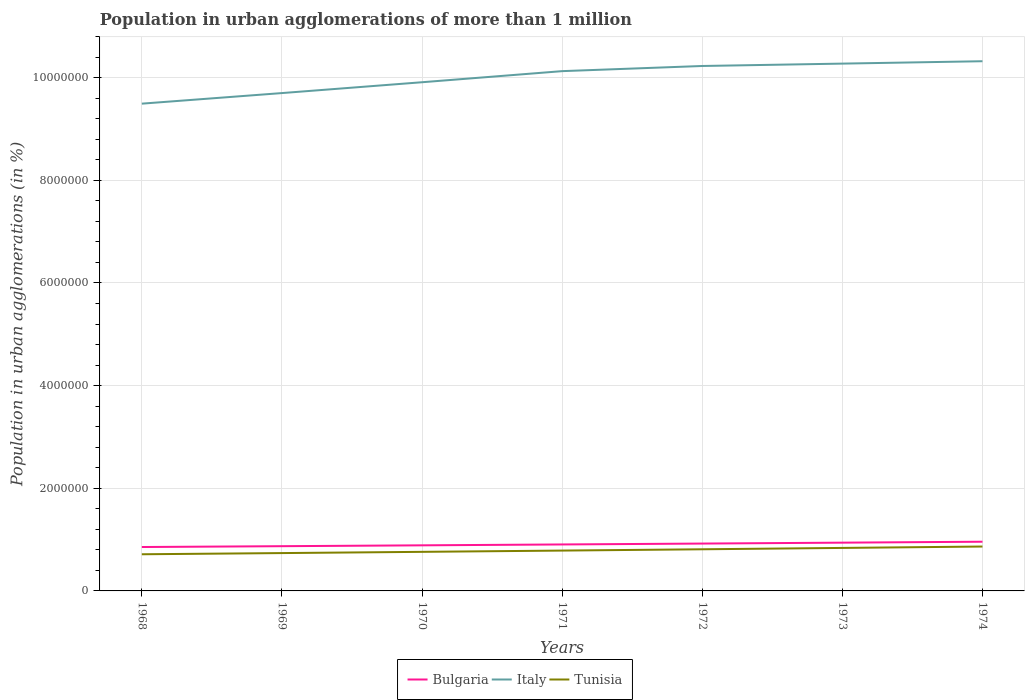Does the line corresponding to Bulgaria intersect with the line corresponding to Tunisia?
Ensure brevity in your answer.  No. Across all years, what is the maximum population in urban agglomerations in Bulgaria?
Make the answer very short. 8.55e+05. In which year was the population in urban agglomerations in Tunisia maximum?
Make the answer very short. 1968. What is the total population in urban agglomerations in Italy in the graph?
Ensure brevity in your answer.  -5.28e+05. What is the difference between the highest and the second highest population in urban agglomerations in Italy?
Your answer should be compact. 8.27e+05. Is the population in urban agglomerations in Tunisia strictly greater than the population in urban agglomerations in Bulgaria over the years?
Your answer should be compact. Yes. How many lines are there?
Give a very brief answer. 3. Are the values on the major ticks of Y-axis written in scientific E-notation?
Give a very brief answer. No. Does the graph contain grids?
Give a very brief answer. Yes. How many legend labels are there?
Give a very brief answer. 3. How are the legend labels stacked?
Make the answer very short. Horizontal. What is the title of the graph?
Offer a terse response. Population in urban agglomerations of more than 1 million. Does "Macedonia" appear as one of the legend labels in the graph?
Provide a short and direct response. No. What is the label or title of the X-axis?
Keep it short and to the point. Years. What is the label or title of the Y-axis?
Your answer should be very brief. Population in urban agglomerations (in %). What is the Population in urban agglomerations (in %) of Bulgaria in 1968?
Offer a very short reply. 8.55e+05. What is the Population in urban agglomerations (in %) of Italy in 1968?
Ensure brevity in your answer.  9.49e+06. What is the Population in urban agglomerations (in %) of Tunisia in 1968?
Offer a very short reply. 7.14e+05. What is the Population in urban agglomerations (in %) of Bulgaria in 1969?
Provide a succinct answer. 8.72e+05. What is the Population in urban agglomerations (in %) of Italy in 1969?
Your answer should be very brief. 9.70e+06. What is the Population in urban agglomerations (in %) of Tunisia in 1969?
Make the answer very short. 7.37e+05. What is the Population in urban agglomerations (in %) in Bulgaria in 1970?
Offer a very short reply. 8.88e+05. What is the Population in urban agglomerations (in %) of Italy in 1970?
Keep it short and to the point. 9.91e+06. What is the Population in urban agglomerations (in %) in Tunisia in 1970?
Ensure brevity in your answer.  7.61e+05. What is the Population in urban agglomerations (in %) of Bulgaria in 1971?
Offer a terse response. 9.05e+05. What is the Population in urban agglomerations (in %) in Italy in 1971?
Give a very brief answer. 1.01e+07. What is the Population in urban agglomerations (in %) in Tunisia in 1971?
Your response must be concise. 7.86e+05. What is the Population in urban agglomerations (in %) of Bulgaria in 1972?
Keep it short and to the point. 9.23e+05. What is the Population in urban agglomerations (in %) in Italy in 1972?
Ensure brevity in your answer.  1.02e+07. What is the Population in urban agglomerations (in %) in Tunisia in 1972?
Give a very brief answer. 8.11e+05. What is the Population in urban agglomerations (in %) in Bulgaria in 1973?
Provide a short and direct response. 9.41e+05. What is the Population in urban agglomerations (in %) of Italy in 1973?
Provide a short and direct response. 1.03e+07. What is the Population in urban agglomerations (in %) in Tunisia in 1973?
Your response must be concise. 8.38e+05. What is the Population in urban agglomerations (in %) in Bulgaria in 1974?
Your response must be concise. 9.59e+05. What is the Population in urban agglomerations (in %) of Italy in 1974?
Make the answer very short. 1.03e+07. What is the Population in urban agglomerations (in %) of Tunisia in 1974?
Offer a terse response. 8.65e+05. Across all years, what is the maximum Population in urban agglomerations (in %) of Bulgaria?
Keep it short and to the point. 9.59e+05. Across all years, what is the maximum Population in urban agglomerations (in %) in Italy?
Provide a short and direct response. 1.03e+07. Across all years, what is the maximum Population in urban agglomerations (in %) in Tunisia?
Ensure brevity in your answer.  8.65e+05. Across all years, what is the minimum Population in urban agglomerations (in %) in Bulgaria?
Ensure brevity in your answer.  8.55e+05. Across all years, what is the minimum Population in urban agglomerations (in %) of Italy?
Your answer should be compact. 9.49e+06. Across all years, what is the minimum Population in urban agglomerations (in %) in Tunisia?
Offer a very short reply. 7.14e+05. What is the total Population in urban agglomerations (in %) of Bulgaria in the graph?
Your response must be concise. 6.34e+06. What is the total Population in urban agglomerations (in %) in Italy in the graph?
Ensure brevity in your answer.  7.01e+07. What is the total Population in urban agglomerations (in %) of Tunisia in the graph?
Provide a short and direct response. 5.51e+06. What is the difference between the Population in urban agglomerations (in %) of Bulgaria in 1968 and that in 1969?
Your response must be concise. -1.64e+04. What is the difference between the Population in urban agglomerations (in %) of Italy in 1968 and that in 1969?
Your answer should be compact. -2.06e+05. What is the difference between the Population in urban agglomerations (in %) in Tunisia in 1968 and that in 1969?
Your answer should be very brief. -2.31e+04. What is the difference between the Population in urban agglomerations (in %) of Bulgaria in 1968 and that in 1970?
Provide a short and direct response. -3.31e+04. What is the difference between the Population in urban agglomerations (in %) of Italy in 1968 and that in 1970?
Provide a short and direct response. -4.17e+05. What is the difference between the Population in urban agglomerations (in %) in Tunisia in 1968 and that in 1970?
Your response must be concise. -4.70e+04. What is the difference between the Population in urban agglomerations (in %) in Bulgaria in 1968 and that in 1971?
Make the answer very short. -5.02e+04. What is the difference between the Population in urban agglomerations (in %) in Italy in 1968 and that in 1971?
Offer a terse response. -6.33e+05. What is the difference between the Population in urban agglomerations (in %) of Tunisia in 1968 and that in 1971?
Give a very brief answer. -7.17e+04. What is the difference between the Population in urban agglomerations (in %) in Bulgaria in 1968 and that in 1972?
Make the answer very short. -6.76e+04. What is the difference between the Population in urban agglomerations (in %) in Italy in 1968 and that in 1972?
Your answer should be compact. -7.34e+05. What is the difference between the Population in urban agglomerations (in %) of Tunisia in 1968 and that in 1972?
Give a very brief answer. -9.72e+04. What is the difference between the Population in urban agglomerations (in %) in Bulgaria in 1968 and that in 1973?
Make the answer very short. -8.52e+04. What is the difference between the Population in urban agglomerations (in %) in Italy in 1968 and that in 1973?
Ensure brevity in your answer.  -7.80e+05. What is the difference between the Population in urban agglomerations (in %) of Tunisia in 1968 and that in 1973?
Your answer should be compact. -1.23e+05. What is the difference between the Population in urban agglomerations (in %) in Bulgaria in 1968 and that in 1974?
Your answer should be very brief. -1.03e+05. What is the difference between the Population in urban agglomerations (in %) of Italy in 1968 and that in 1974?
Offer a very short reply. -8.27e+05. What is the difference between the Population in urban agglomerations (in %) of Tunisia in 1968 and that in 1974?
Provide a short and direct response. -1.51e+05. What is the difference between the Population in urban agglomerations (in %) of Bulgaria in 1969 and that in 1970?
Provide a short and direct response. -1.67e+04. What is the difference between the Population in urban agglomerations (in %) of Italy in 1969 and that in 1970?
Provide a short and direct response. -2.11e+05. What is the difference between the Population in urban agglomerations (in %) in Tunisia in 1969 and that in 1970?
Provide a succinct answer. -2.39e+04. What is the difference between the Population in urban agglomerations (in %) in Bulgaria in 1969 and that in 1971?
Your answer should be compact. -3.38e+04. What is the difference between the Population in urban agglomerations (in %) in Italy in 1969 and that in 1971?
Your answer should be compact. -4.27e+05. What is the difference between the Population in urban agglomerations (in %) of Tunisia in 1969 and that in 1971?
Your response must be concise. -4.86e+04. What is the difference between the Population in urban agglomerations (in %) of Bulgaria in 1969 and that in 1972?
Provide a short and direct response. -5.12e+04. What is the difference between the Population in urban agglomerations (in %) in Italy in 1969 and that in 1972?
Offer a very short reply. -5.28e+05. What is the difference between the Population in urban agglomerations (in %) of Tunisia in 1969 and that in 1972?
Make the answer very short. -7.41e+04. What is the difference between the Population in urban agglomerations (in %) of Bulgaria in 1969 and that in 1973?
Offer a terse response. -6.88e+04. What is the difference between the Population in urban agglomerations (in %) of Italy in 1969 and that in 1973?
Your answer should be very brief. -5.74e+05. What is the difference between the Population in urban agglomerations (in %) of Tunisia in 1969 and that in 1973?
Your answer should be very brief. -1.00e+05. What is the difference between the Population in urban agglomerations (in %) in Bulgaria in 1969 and that in 1974?
Make the answer very short. -8.69e+04. What is the difference between the Population in urban agglomerations (in %) in Italy in 1969 and that in 1974?
Ensure brevity in your answer.  -6.20e+05. What is the difference between the Population in urban agglomerations (in %) in Tunisia in 1969 and that in 1974?
Your response must be concise. -1.27e+05. What is the difference between the Population in urban agglomerations (in %) of Bulgaria in 1970 and that in 1971?
Your answer should be compact. -1.70e+04. What is the difference between the Population in urban agglomerations (in %) in Italy in 1970 and that in 1971?
Offer a terse response. -2.16e+05. What is the difference between the Population in urban agglomerations (in %) of Tunisia in 1970 and that in 1971?
Provide a short and direct response. -2.47e+04. What is the difference between the Population in urban agglomerations (in %) of Bulgaria in 1970 and that in 1972?
Your response must be concise. -3.44e+04. What is the difference between the Population in urban agglomerations (in %) of Italy in 1970 and that in 1972?
Ensure brevity in your answer.  -3.17e+05. What is the difference between the Population in urban agglomerations (in %) of Tunisia in 1970 and that in 1972?
Give a very brief answer. -5.02e+04. What is the difference between the Population in urban agglomerations (in %) in Bulgaria in 1970 and that in 1973?
Make the answer very short. -5.21e+04. What is the difference between the Population in urban agglomerations (in %) in Italy in 1970 and that in 1973?
Ensure brevity in your answer.  -3.63e+05. What is the difference between the Population in urban agglomerations (in %) in Tunisia in 1970 and that in 1973?
Your answer should be compact. -7.64e+04. What is the difference between the Population in urban agglomerations (in %) of Bulgaria in 1970 and that in 1974?
Offer a terse response. -7.02e+04. What is the difference between the Population in urban agglomerations (in %) in Italy in 1970 and that in 1974?
Your response must be concise. -4.09e+05. What is the difference between the Population in urban agglomerations (in %) of Tunisia in 1970 and that in 1974?
Offer a very short reply. -1.04e+05. What is the difference between the Population in urban agglomerations (in %) in Bulgaria in 1971 and that in 1972?
Provide a succinct answer. -1.74e+04. What is the difference between the Population in urban agglomerations (in %) in Italy in 1971 and that in 1972?
Keep it short and to the point. -1.01e+05. What is the difference between the Population in urban agglomerations (in %) in Tunisia in 1971 and that in 1972?
Provide a succinct answer. -2.55e+04. What is the difference between the Population in urban agglomerations (in %) of Bulgaria in 1971 and that in 1973?
Offer a terse response. -3.51e+04. What is the difference between the Population in urban agglomerations (in %) in Italy in 1971 and that in 1973?
Make the answer very short. -1.47e+05. What is the difference between the Population in urban agglomerations (in %) of Tunisia in 1971 and that in 1973?
Provide a short and direct response. -5.18e+04. What is the difference between the Population in urban agglomerations (in %) of Bulgaria in 1971 and that in 1974?
Your answer should be very brief. -5.31e+04. What is the difference between the Population in urban agglomerations (in %) in Italy in 1971 and that in 1974?
Your answer should be compact. -1.93e+05. What is the difference between the Population in urban agglomerations (in %) in Tunisia in 1971 and that in 1974?
Provide a short and direct response. -7.89e+04. What is the difference between the Population in urban agglomerations (in %) in Bulgaria in 1972 and that in 1973?
Your answer should be very brief. -1.77e+04. What is the difference between the Population in urban agglomerations (in %) in Italy in 1972 and that in 1973?
Offer a very short reply. -4.61e+04. What is the difference between the Population in urban agglomerations (in %) of Tunisia in 1972 and that in 1973?
Provide a short and direct response. -2.63e+04. What is the difference between the Population in urban agglomerations (in %) in Bulgaria in 1972 and that in 1974?
Provide a short and direct response. -3.57e+04. What is the difference between the Population in urban agglomerations (in %) of Italy in 1972 and that in 1974?
Offer a very short reply. -9.26e+04. What is the difference between the Population in urban agglomerations (in %) in Tunisia in 1972 and that in 1974?
Your answer should be very brief. -5.34e+04. What is the difference between the Population in urban agglomerations (in %) in Bulgaria in 1973 and that in 1974?
Make the answer very short. -1.80e+04. What is the difference between the Population in urban agglomerations (in %) of Italy in 1973 and that in 1974?
Your answer should be compact. -4.65e+04. What is the difference between the Population in urban agglomerations (in %) of Tunisia in 1973 and that in 1974?
Provide a succinct answer. -2.71e+04. What is the difference between the Population in urban agglomerations (in %) of Bulgaria in 1968 and the Population in urban agglomerations (in %) of Italy in 1969?
Provide a short and direct response. -8.85e+06. What is the difference between the Population in urban agglomerations (in %) in Bulgaria in 1968 and the Population in urban agglomerations (in %) in Tunisia in 1969?
Give a very brief answer. 1.18e+05. What is the difference between the Population in urban agglomerations (in %) of Italy in 1968 and the Population in urban agglomerations (in %) of Tunisia in 1969?
Offer a very short reply. 8.76e+06. What is the difference between the Population in urban agglomerations (in %) of Bulgaria in 1968 and the Population in urban agglomerations (in %) of Italy in 1970?
Your answer should be very brief. -9.06e+06. What is the difference between the Population in urban agglomerations (in %) in Bulgaria in 1968 and the Population in urban agglomerations (in %) in Tunisia in 1970?
Provide a short and direct response. 9.40e+04. What is the difference between the Population in urban agglomerations (in %) in Italy in 1968 and the Population in urban agglomerations (in %) in Tunisia in 1970?
Keep it short and to the point. 8.73e+06. What is the difference between the Population in urban agglomerations (in %) in Bulgaria in 1968 and the Population in urban agglomerations (in %) in Italy in 1971?
Your response must be concise. -9.27e+06. What is the difference between the Population in urban agglomerations (in %) in Bulgaria in 1968 and the Population in urban agglomerations (in %) in Tunisia in 1971?
Your answer should be very brief. 6.94e+04. What is the difference between the Population in urban agglomerations (in %) in Italy in 1968 and the Population in urban agglomerations (in %) in Tunisia in 1971?
Provide a succinct answer. 8.71e+06. What is the difference between the Population in urban agglomerations (in %) in Bulgaria in 1968 and the Population in urban agglomerations (in %) in Italy in 1972?
Give a very brief answer. -9.37e+06. What is the difference between the Population in urban agglomerations (in %) of Bulgaria in 1968 and the Population in urban agglomerations (in %) of Tunisia in 1972?
Offer a terse response. 4.39e+04. What is the difference between the Population in urban agglomerations (in %) of Italy in 1968 and the Population in urban agglomerations (in %) of Tunisia in 1972?
Make the answer very short. 8.68e+06. What is the difference between the Population in urban agglomerations (in %) of Bulgaria in 1968 and the Population in urban agglomerations (in %) of Italy in 1973?
Offer a very short reply. -9.42e+06. What is the difference between the Population in urban agglomerations (in %) of Bulgaria in 1968 and the Population in urban agglomerations (in %) of Tunisia in 1973?
Provide a succinct answer. 1.76e+04. What is the difference between the Population in urban agglomerations (in %) in Italy in 1968 and the Population in urban agglomerations (in %) in Tunisia in 1973?
Your answer should be very brief. 8.66e+06. What is the difference between the Population in urban agglomerations (in %) of Bulgaria in 1968 and the Population in urban agglomerations (in %) of Italy in 1974?
Give a very brief answer. -9.47e+06. What is the difference between the Population in urban agglomerations (in %) in Bulgaria in 1968 and the Population in urban agglomerations (in %) in Tunisia in 1974?
Your answer should be very brief. -9540. What is the difference between the Population in urban agglomerations (in %) of Italy in 1968 and the Population in urban agglomerations (in %) of Tunisia in 1974?
Provide a short and direct response. 8.63e+06. What is the difference between the Population in urban agglomerations (in %) in Bulgaria in 1969 and the Population in urban agglomerations (in %) in Italy in 1970?
Your answer should be compact. -9.04e+06. What is the difference between the Population in urban agglomerations (in %) in Bulgaria in 1969 and the Population in urban agglomerations (in %) in Tunisia in 1970?
Your response must be concise. 1.10e+05. What is the difference between the Population in urban agglomerations (in %) in Italy in 1969 and the Population in urban agglomerations (in %) in Tunisia in 1970?
Provide a succinct answer. 8.94e+06. What is the difference between the Population in urban agglomerations (in %) in Bulgaria in 1969 and the Population in urban agglomerations (in %) in Italy in 1971?
Your response must be concise. -9.26e+06. What is the difference between the Population in urban agglomerations (in %) in Bulgaria in 1969 and the Population in urban agglomerations (in %) in Tunisia in 1971?
Make the answer very short. 8.57e+04. What is the difference between the Population in urban agglomerations (in %) in Italy in 1969 and the Population in urban agglomerations (in %) in Tunisia in 1971?
Your response must be concise. 8.91e+06. What is the difference between the Population in urban agglomerations (in %) of Bulgaria in 1969 and the Population in urban agglomerations (in %) of Italy in 1972?
Ensure brevity in your answer.  -9.36e+06. What is the difference between the Population in urban agglomerations (in %) in Bulgaria in 1969 and the Population in urban agglomerations (in %) in Tunisia in 1972?
Your answer should be compact. 6.02e+04. What is the difference between the Population in urban agglomerations (in %) of Italy in 1969 and the Population in urban agglomerations (in %) of Tunisia in 1972?
Make the answer very short. 8.89e+06. What is the difference between the Population in urban agglomerations (in %) of Bulgaria in 1969 and the Population in urban agglomerations (in %) of Italy in 1973?
Offer a terse response. -9.40e+06. What is the difference between the Population in urban agglomerations (in %) in Bulgaria in 1969 and the Population in urban agglomerations (in %) in Tunisia in 1973?
Keep it short and to the point. 3.40e+04. What is the difference between the Population in urban agglomerations (in %) of Italy in 1969 and the Population in urban agglomerations (in %) of Tunisia in 1973?
Offer a terse response. 8.86e+06. What is the difference between the Population in urban agglomerations (in %) in Bulgaria in 1969 and the Population in urban agglomerations (in %) in Italy in 1974?
Provide a succinct answer. -9.45e+06. What is the difference between the Population in urban agglomerations (in %) of Bulgaria in 1969 and the Population in urban agglomerations (in %) of Tunisia in 1974?
Ensure brevity in your answer.  6847. What is the difference between the Population in urban agglomerations (in %) of Italy in 1969 and the Population in urban agglomerations (in %) of Tunisia in 1974?
Give a very brief answer. 8.84e+06. What is the difference between the Population in urban agglomerations (in %) of Bulgaria in 1970 and the Population in urban agglomerations (in %) of Italy in 1971?
Offer a very short reply. -9.24e+06. What is the difference between the Population in urban agglomerations (in %) in Bulgaria in 1970 and the Population in urban agglomerations (in %) in Tunisia in 1971?
Ensure brevity in your answer.  1.02e+05. What is the difference between the Population in urban agglomerations (in %) of Italy in 1970 and the Population in urban agglomerations (in %) of Tunisia in 1971?
Your response must be concise. 9.13e+06. What is the difference between the Population in urban agglomerations (in %) of Bulgaria in 1970 and the Population in urban agglomerations (in %) of Italy in 1972?
Ensure brevity in your answer.  -9.34e+06. What is the difference between the Population in urban agglomerations (in %) of Bulgaria in 1970 and the Population in urban agglomerations (in %) of Tunisia in 1972?
Your answer should be very brief. 7.70e+04. What is the difference between the Population in urban agglomerations (in %) of Italy in 1970 and the Population in urban agglomerations (in %) of Tunisia in 1972?
Your answer should be compact. 9.10e+06. What is the difference between the Population in urban agglomerations (in %) in Bulgaria in 1970 and the Population in urban agglomerations (in %) in Italy in 1973?
Give a very brief answer. -9.39e+06. What is the difference between the Population in urban agglomerations (in %) in Bulgaria in 1970 and the Population in urban agglomerations (in %) in Tunisia in 1973?
Provide a succinct answer. 5.07e+04. What is the difference between the Population in urban agglomerations (in %) in Italy in 1970 and the Population in urban agglomerations (in %) in Tunisia in 1973?
Provide a short and direct response. 9.07e+06. What is the difference between the Population in urban agglomerations (in %) in Bulgaria in 1970 and the Population in urban agglomerations (in %) in Italy in 1974?
Your response must be concise. -9.43e+06. What is the difference between the Population in urban agglomerations (in %) of Bulgaria in 1970 and the Population in urban agglomerations (in %) of Tunisia in 1974?
Your answer should be very brief. 2.36e+04. What is the difference between the Population in urban agglomerations (in %) of Italy in 1970 and the Population in urban agglomerations (in %) of Tunisia in 1974?
Provide a short and direct response. 9.05e+06. What is the difference between the Population in urban agglomerations (in %) of Bulgaria in 1971 and the Population in urban agglomerations (in %) of Italy in 1972?
Offer a terse response. -9.32e+06. What is the difference between the Population in urban agglomerations (in %) of Bulgaria in 1971 and the Population in urban agglomerations (in %) of Tunisia in 1972?
Your response must be concise. 9.40e+04. What is the difference between the Population in urban agglomerations (in %) of Italy in 1971 and the Population in urban agglomerations (in %) of Tunisia in 1972?
Offer a very short reply. 9.32e+06. What is the difference between the Population in urban agglomerations (in %) of Bulgaria in 1971 and the Population in urban agglomerations (in %) of Italy in 1973?
Your answer should be very brief. -9.37e+06. What is the difference between the Population in urban agglomerations (in %) of Bulgaria in 1971 and the Population in urban agglomerations (in %) of Tunisia in 1973?
Your response must be concise. 6.78e+04. What is the difference between the Population in urban agglomerations (in %) of Italy in 1971 and the Population in urban agglomerations (in %) of Tunisia in 1973?
Your response must be concise. 9.29e+06. What is the difference between the Population in urban agglomerations (in %) of Bulgaria in 1971 and the Population in urban agglomerations (in %) of Italy in 1974?
Provide a succinct answer. -9.42e+06. What is the difference between the Population in urban agglomerations (in %) of Bulgaria in 1971 and the Population in urban agglomerations (in %) of Tunisia in 1974?
Offer a very short reply. 4.06e+04. What is the difference between the Population in urban agglomerations (in %) of Italy in 1971 and the Population in urban agglomerations (in %) of Tunisia in 1974?
Keep it short and to the point. 9.26e+06. What is the difference between the Population in urban agglomerations (in %) in Bulgaria in 1972 and the Population in urban agglomerations (in %) in Italy in 1973?
Provide a short and direct response. -9.35e+06. What is the difference between the Population in urban agglomerations (in %) of Bulgaria in 1972 and the Population in urban agglomerations (in %) of Tunisia in 1973?
Give a very brief answer. 8.52e+04. What is the difference between the Population in urban agglomerations (in %) in Italy in 1972 and the Population in urban agglomerations (in %) in Tunisia in 1973?
Your response must be concise. 9.39e+06. What is the difference between the Population in urban agglomerations (in %) in Bulgaria in 1972 and the Population in urban agglomerations (in %) in Italy in 1974?
Make the answer very short. -9.40e+06. What is the difference between the Population in urban agglomerations (in %) in Bulgaria in 1972 and the Population in urban agglomerations (in %) in Tunisia in 1974?
Your answer should be very brief. 5.80e+04. What is the difference between the Population in urban agglomerations (in %) in Italy in 1972 and the Population in urban agglomerations (in %) in Tunisia in 1974?
Your response must be concise. 9.36e+06. What is the difference between the Population in urban agglomerations (in %) of Bulgaria in 1973 and the Population in urban agglomerations (in %) of Italy in 1974?
Your response must be concise. -9.38e+06. What is the difference between the Population in urban agglomerations (in %) of Bulgaria in 1973 and the Population in urban agglomerations (in %) of Tunisia in 1974?
Offer a very short reply. 7.57e+04. What is the difference between the Population in urban agglomerations (in %) in Italy in 1973 and the Population in urban agglomerations (in %) in Tunisia in 1974?
Give a very brief answer. 9.41e+06. What is the average Population in urban agglomerations (in %) of Bulgaria per year?
Your response must be concise. 9.06e+05. What is the average Population in urban agglomerations (in %) in Italy per year?
Your response must be concise. 1.00e+07. What is the average Population in urban agglomerations (in %) in Tunisia per year?
Make the answer very short. 7.88e+05. In the year 1968, what is the difference between the Population in urban agglomerations (in %) of Bulgaria and Population in urban agglomerations (in %) of Italy?
Your answer should be compact. -8.64e+06. In the year 1968, what is the difference between the Population in urban agglomerations (in %) in Bulgaria and Population in urban agglomerations (in %) in Tunisia?
Make the answer very short. 1.41e+05. In the year 1968, what is the difference between the Population in urban agglomerations (in %) in Italy and Population in urban agglomerations (in %) in Tunisia?
Your answer should be very brief. 8.78e+06. In the year 1969, what is the difference between the Population in urban agglomerations (in %) of Bulgaria and Population in urban agglomerations (in %) of Italy?
Your response must be concise. -8.83e+06. In the year 1969, what is the difference between the Population in urban agglomerations (in %) in Bulgaria and Population in urban agglomerations (in %) in Tunisia?
Provide a succinct answer. 1.34e+05. In the year 1969, what is the difference between the Population in urban agglomerations (in %) of Italy and Population in urban agglomerations (in %) of Tunisia?
Provide a succinct answer. 8.96e+06. In the year 1970, what is the difference between the Population in urban agglomerations (in %) of Bulgaria and Population in urban agglomerations (in %) of Italy?
Give a very brief answer. -9.02e+06. In the year 1970, what is the difference between the Population in urban agglomerations (in %) in Bulgaria and Population in urban agglomerations (in %) in Tunisia?
Your answer should be compact. 1.27e+05. In the year 1970, what is the difference between the Population in urban agglomerations (in %) of Italy and Population in urban agglomerations (in %) of Tunisia?
Offer a terse response. 9.15e+06. In the year 1971, what is the difference between the Population in urban agglomerations (in %) in Bulgaria and Population in urban agglomerations (in %) in Italy?
Provide a succinct answer. -9.22e+06. In the year 1971, what is the difference between the Population in urban agglomerations (in %) in Bulgaria and Population in urban agglomerations (in %) in Tunisia?
Your answer should be very brief. 1.20e+05. In the year 1971, what is the difference between the Population in urban agglomerations (in %) of Italy and Population in urban agglomerations (in %) of Tunisia?
Your response must be concise. 9.34e+06. In the year 1972, what is the difference between the Population in urban agglomerations (in %) in Bulgaria and Population in urban agglomerations (in %) in Italy?
Offer a terse response. -9.31e+06. In the year 1972, what is the difference between the Population in urban agglomerations (in %) of Bulgaria and Population in urban agglomerations (in %) of Tunisia?
Offer a very short reply. 1.11e+05. In the year 1972, what is the difference between the Population in urban agglomerations (in %) in Italy and Population in urban agglomerations (in %) in Tunisia?
Provide a succinct answer. 9.42e+06. In the year 1973, what is the difference between the Population in urban agglomerations (in %) of Bulgaria and Population in urban agglomerations (in %) of Italy?
Ensure brevity in your answer.  -9.33e+06. In the year 1973, what is the difference between the Population in urban agglomerations (in %) of Bulgaria and Population in urban agglomerations (in %) of Tunisia?
Offer a terse response. 1.03e+05. In the year 1973, what is the difference between the Population in urban agglomerations (in %) of Italy and Population in urban agglomerations (in %) of Tunisia?
Keep it short and to the point. 9.44e+06. In the year 1974, what is the difference between the Population in urban agglomerations (in %) of Bulgaria and Population in urban agglomerations (in %) of Italy?
Offer a terse response. -9.36e+06. In the year 1974, what is the difference between the Population in urban agglomerations (in %) in Bulgaria and Population in urban agglomerations (in %) in Tunisia?
Provide a short and direct response. 9.37e+04. In the year 1974, what is the difference between the Population in urban agglomerations (in %) of Italy and Population in urban agglomerations (in %) of Tunisia?
Provide a short and direct response. 9.46e+06. What is the ratio of the Population in urban agglomerations (in %) in Bulgaria in 1968 to that in 1969?
Keep it short and to the point. 0.98. What is the ratio of the Population in urban agglomerations (in %) in Italy in 1968 to that in 1969?
Provide a succinct answer. 0.98. What is the ratio of the Population in urban agglomerations (in %) in Tunisia in 1968 to that in 1969?
Your answer should be compact. 0.97. What is the ratio of the Population in urban agglomerations (in %) of Bulgaria in 1968 to that in 1970?
Keep it short and to the point. 0.96. What is the ratio of the Population in urban agglomerations (in %) of Italy in 1968 to that in 1970?
Make the answer very short. 0.96. What is the ratio of the Population in urban agglomerations (in %) in Tunisia in 1968 to that in 1970?
Provide a succinct answer. 0.94. What is the ratio of the Population in urban agglomerations (in %) of Bulgaria in 1968 to that in 1971?
Provide a succinct answer. 0.94. What is the ratio of the Population in urban agglomerations (in %) of Italy in 1968 to that in 1971?
Your answer should be very brief. 0.94. What is the ratio of the Population in urban agglomerations (in %) of Tunisia in 1968 to that in 1971?
Your answer should be compact. 0.91. What is the ratio of the Population in urban agglomerations (in %) of Bulgaria in 1968 to that in 1972?
Provide a succinct answer. 0.93. What is the ratio of the Population in urban agglomerations (in %) of Italy in 1968 to that in 1972?
Your response must be concise. 0.93. What is the ratio of the Population in urban agglomerations (in %) in Tunisia in 1968 to that in 1972?
Offer a terse response. 0.88. What is the ratio of the Population in urban agglomerations (in %) of Bulgaria in 1968 to that in 1973?
Provide a succinct answer. 0.91. What is the ratio of the Population in urban agglomerations (in %) in Italy in 1968 to that in 1973?
Make the answer very short. 0.92. What is the ratio of the Population in urban agglomerations (in %) in Tunisia in 1968 to that in 1973?
Keep it short and to the point. 0.85. What is the ratio of the Population in urban agglomerations (in %) of Bulgaria in 1968 to that in 1974?
Make the answer very short. 0.89. What is the ratio of the Population in urban agglomerations (in %) of Italy in 1968 to that in 1974?
Provide a short and direct response. 0.92. What is the ratio of the Population in urban agglomerations (in %) of Tunisia in 1968 to that in 1974?
Provide a short and direct response. 0.83. What is the ratio of the Population in urban agglomerations (in %) in Bulgaria in 1969 to that in 1970?
Keep it short and to the point. 0.98. What is the ratio of the Population in urban agglomerations (in %) in Italy in 1969 to that in 1970?
Your answer should be very brief. 0.98. What is the ratio of the Population in urban agglomerations (in %) in Tunisia in 1969 to that in 1970?
Your response must be concise. 0.97. What is the ratio of the Population in urban agglomerations (in %) of Bulgaria in 1969 to that in 1971?
Give a very brief answer. 0.96. What is the ratio of the Population in urban agglomerations (in %) in Italy in 1969 to that in 1971?
Keep it short and to the point. 0.96. What is the ratio of the Population in urban agglomerations (in %) of Tunisia in 1969 to that in 1971?
Your answer should be very brief. 0.94. What is the ratio of the Population in urban agglomerations (in %) of Bulgaria in 1969 to that in 1972?
Offer a terse response. 0.94. What is the ratio of the Population in urban agglomerations (in %) of Italy in 1969 to that in 1972?
Make the answer very short. 0.95. What is the ratio of the Population in urban agglomerations (in %) of Tunisia in 1969 to that in 1972?
Make the answer very short. 0.91. What is the ratio of the Population in urban agglomerations (in %) of Bulgaria in 1969 to that in 1973?
Provide a short and direct response. 0.93. What is the ratio of the Population in urban agglomerations (in %) of Italy in 1969 to that in 1973?
Your answer should be very brief. 0.94. What is the ratio of the Population in urban agglomerations (in %) in Tunisia in 1969 to that in 1973?
Your answer should be very brief. 0.88. What is the ratio of the Population in urban agglomerations (in %) of Bulgaria in 1969 to that in 1974?
Offer a very short reply. 0.91. What is the ratio of the Population in urban agglomerations (in %) in Italy in 1969 to that in 1974?
Provide a succinct answer. 0.94. What is the ratio of the Population in urban agglomerations (in %) in Tunisia in 1969 to that in 1974?
Give a very brief answer. 0.85. What is the ratio of the Population in urban agglomerations (in %) in Bulgaria in 1970 to that in 1971?
Provide a short and direct response. 0.98. What is the ratio of the Population in urban agglomerations (in %) of Italy in 1970 to that in 1971?
Provide a short and direct response. 0.98. What is the ratio of the Population in urban agglomerations (in %) of Tunisia in 1970 to that in 1971?
Offer a very short reply. 0.97. What is the ratio of the Population in urban agglomerations (in %) in Bulgaria in 1970 to that in 1972?
Offer a terse response. 0.96. What is the ratio of the Population in urban agglomerations (in %) of Italy in 1970 to that in 1972?
Provide a succinct answer. 0.97. What is the ratio of the Population in urban agglomerations (in %) in Tunisia in 1970 to that in 1972?
Give a very brief answer. 0.94. What is the ratio of the Population in urban agglomerations (in %) of Bulgaria in 1970 to that in 1973?
Your answer should be very brief. 0.94. What is the ratio of the Population in urban agglomerations (in %) in Italy in 1970 to that in 1973?
Provide a short and direct response. 0.96. What is the ratio of the Population in urban agglomerations (in %) in Tunisia in 1970 to that in 1973?
Your response must be concise. 0.91. What is the ratio of the Population in urban agglomerations (in %) in Bulgaria in 1970 to that in 1974?
Your answer should be compact. 0.93. What is the ratio of the Population in urban agglomerations (in %) in Italy in 1970 to that in 1974?
Make the answer very short. 0.96. What is the ratio of the Population in urban agglomerations (in %) in Tunisia in 1970 to that in 1974?
Your answer should be compact. 0.88. What is the ratio of the Population in urban agglomerations (in %) of Bulgaria in 1971 to that in 1972?
Offer a very short reply. 0.98. What is the ratio of the Population in urban agglomerations (in %) in Italy in 1971 to that in 1972?
Your answer should be compact. 0.99. What is the ratio of the Population in urban agglomerations (in %) in Tunisia in 1971 to that in 1972?
Your answer should be very brief. 0.97. What is the ratio of the Population in urban agglomerations (in %) of Bulgaria in 1971 to that in 1973?
Your response must be concise. 0.96. What is the ratio of the Population in urban agglomerations (in %) of Italy in 1971 to that in 1973?
Offer a terse response. 0.99. What is the ratio of the Population in urban agglomerations (in %) in Tunisia in 1971 to that in 1973?
Provide a short and direct response. 0.94. What is the ratio of the Population in urban agglomerations (in %) in Bulgaria in 1971 to that in 1974?
Keep it short and to the point. 0.94. What is the ratio of the Population in urban agglomerations (in %) of Italy in 1971 to that in 1974?
Your answer should be very brief. 0.98. What is the ratio of the Population in urban agglomerations (in %) in Tunisia in 1971 to that in 1974?
Ensure brevity in your answer.  0.91. What is the ratio of the Population in urban agglomerations (in %) in Bulgaria in 1972 to that in 1973?
Keep it short and to the point. 0.98. What is the ratio of the Population in urban agglomerations (in %) of Italy in 1972 to that in 1973?
Your answer should be compact. 1. What is the ratio of the Population in urban agglomerations (in %) of Tunisia in 1972 to that in 1973?
Offer a very short reply. 0.97. What is the ratio of the Population in urban agglomerations (in %) of Bulgaria in 1972 to that in 1974?
Make the answer very short. 0.96. What is the ratio of the Population in urban agglomerations (in %) of Italy in 1972 to that in 1974?
Your response must be concise. 0.99. What is the ratio of the Population in urban agglomerations (in %) of Tunisia in 1972 to that in 1974?
Your answer should be very brief. 0.94. What is the ratio of the Population in urban agglomerations (in %) in Bulgaria in 1973 to that in 1974?
Keep it short and to the point. 0.98. What is the ratio of the Population in urban agglomerations (in %) in Italy in 1973 to that in 1974?
Give a very brief answer. 1. What is the ratio of the Population in urban agglomerations (in %) in Tunisia in 1973 to that in 1974?
Give a very brief answer. 0.97. What is the difference between the highest and the second highest Population in urban agglomerations (in %) in Bulgaria?
Give a very brief answer. 1.80e+04. What is the difference between the highest and the second highest Population in urban agglomerations (in %) of Italy?
Provide a short and direct response. 4.65e+04. What is the difference between the highest and the second highest Population in urban agglomerations (in %) of Tunisia?
Your answer should be very brief. 2.71e+04. What is the difference between the highest and the lowest Population in urban agglomerations (in %) in Bulgaria?
Your answer should be very brief. 1.03e+05. What is the difference between the highest and the lowest Population in urban agglomerations (in %) of Italy?
Provide a short and direct response. 8.27e+05. What is the difference between the highest and the lowest Population in urban agglomerations (in %) of Tunisia?
Offer a terse response. 1.51e+05. 